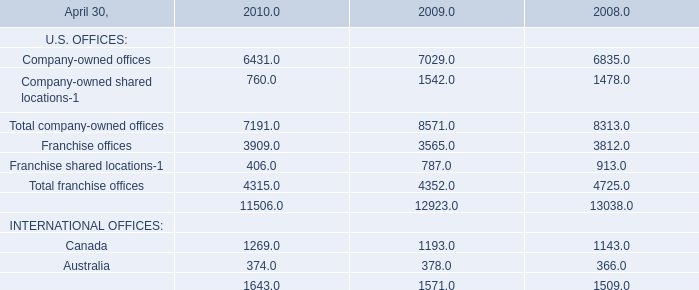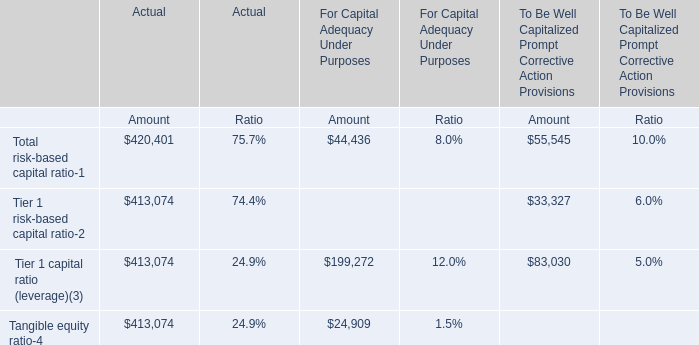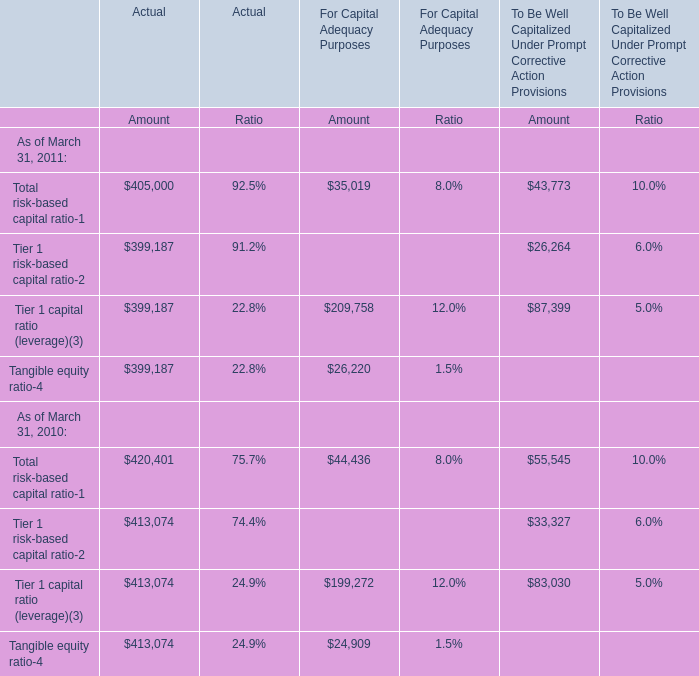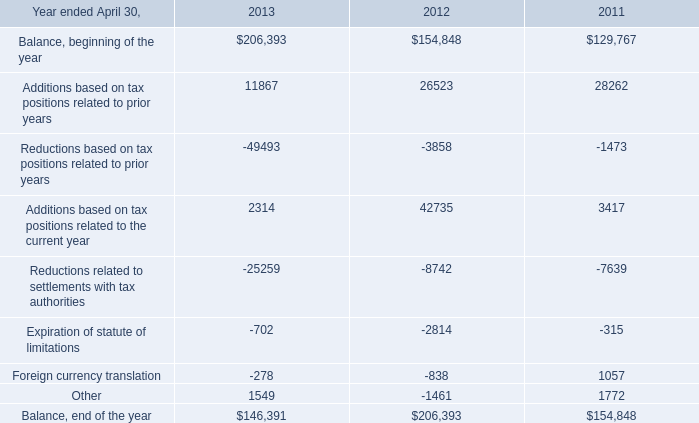what's the total amount of Tangible equity ratio of For Capital Adequacy Purposes Amount, and Reductions related to settlements with tax authorities of 2012 ? 
Computations: (26220.0 + 8742.0)
Answer: 34962.0. 